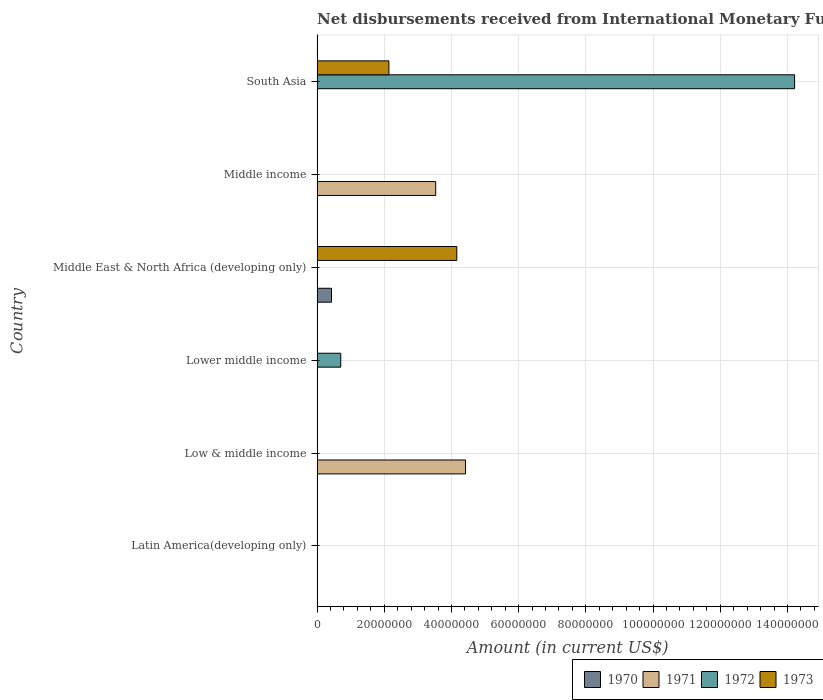How many different coloured bars are there?
Offer a terse response. 4. Are the number of bars per tick equal to the number of legend labels?
Provide a succinct answer. No. Are the number of bars on each tick of the Y-axis equal?
Make the answer very short. No. How many bars are there on the 4th tick from the top?
Offer a very short reply. 1. How many bars are there on the 2nd tick from the bottom?
Your response must be concise. 1. In how many cases, is the number of bars for a given country not equal to the number of legend labels?
Make the answer very short. 6. What is the amount of disbursements received from International Monetary Fund in 1973 in Middle income?
Offer a terse response. 0. Across all countries, what is the maximum amount of disbursements received from International Monetary Fund in 1971?
Provide a succinct answer. 4.42e+07. In which country was the amount of disbursements received from International Monetary Fund in 1971 maximum?
Your response must be concise. Low & middle income. What is the total amount of disbursements received from International Monetary Fund in 1970 in the graph?
Ensure brevity in your answer.  4.30e+06. What is the difference between the amount of disbursements received from International Monetary Fund in 1973 in Lower middle income and the amount of disbursements received from International Monetary Fund in 1970 in Middle East & North Africa (developing only)?
Your response must be concise. -4.30e+06. What is the average amount of disbursements received from International Monetary Fund in 1970 per country?
Ensure brevity in your answer.  7.17e+05. Is the amount of disbursements received from International Monetary Fund in 1972 in Lower middle income less than that in South Asia?
Give a very brief answer. Yes. What is the difference between the highest and the lowest amount of disbursements received from International Monetary Fund in 1970?
Offer a very short reply. 4.30e+06. How many bars are there?
Your response must be concise. 7. Are all the bars in the graph horizontal?
Provide a succinct answer. Yes. Does the graph contain any zero values?
Your answer should be very brief. Yes. Does the graph contain grids?
Give a very brief answer. Yes. Where does the legend appear in the graph?
Your response must be concise. Bottom right. How many legend labels are there?
Offer a terse response. 4. How are the legend labels stacked?
Offer a very short reply. Horizontal. What is the title of the graph?
Provide a succinct answer. Net disbursements received from International Monetary Fund (non-concessional). Does "2005" appear as one of the legend labels in the graph?
Provide a succinct answer. No. What is the label or title of the Y-axis?
Provide a succinct answer. Country. What is the Amount (in current US$) in 1971 in Latin America(developing only)?
Offer a terse response. 0. What is the Amount (in current US$) in 1973 in Latin America(developing only)?
Your answer should be compact. 0. What is the Amount (in current US$) in 1971 in Low & middle income?
Keep it short and to the point. 4.42e+07. What is the Amount (in current US$) in 1973 in Low & middle income?
Your answer should be very brief. 0. What is the Amount (in current US$) of 1970 in Lower middle income?
Your answer should be very brief. 0. What is the Amount (in current US$) of 1972 in Lower middle income?
Your response must be concise. 7.06e+06. What is the Amount (in current US$) of 1970 in Middle East & North Africa (developing only)?
Your response must be concise. 4.30e+06. What is the Amount (in current US$) of 1973 in Middle East & North Africa (developing only)?
Make the answer very short. 4.16e+07. What is the Amount (in current US$) in 1970 in Middle income?
Keep it short and to the point. 0. What is the Amount (in current US$) of 1971 in Middle income?
Your answer should be very brief. 3.53e+07. What is the Amount (in current US$) of 1972 in Middle income?
Ensure brevity in your answer.  0. What is the Amount (in current US$) of 1971 in South Asia?
Your answer should be compact. 0. What is the Amount (in current US$) of 1972 in South Asia?
Your answer should be compact. 1.42e+08. What is the Amount (in current US$) of 1973 in South Asia?
Provide a short and direct response. 2.14e+07. Across all countries, what is the maximum Amount (in current US$) in 1970?
Ensure brevity in your answer.  4.30e+06. Across all countries, what is the maximum Amount (in current US$) in 1971?
Provide a succinct answer. 4.42e+07. Across all countries, what is the maximum Amount (in current US$) of 1972?
Give a very brief answer. 1.42e+08. Across all countries, what is the maximum Amount (in current US$) of 1973?
Offer a terse response. 4.16e+07. Across all countries, what is the minimum Amount (in current US$) of 1971?
Provide a short and direct response. 0. Across all countries, what is the minimum Amount (in current US$) of 1973?
Your answer should be compact. 0. What is the total Amount (in current US$) in 1970 in the graph?
Your answer should be compact. 4.30e+06. What is the total Amount (in current US$) in 1971 in the graph?
Your answer should be very brief. 7.95e+07. What is the total Amount (in current US$) of 1972 in the graph?
Offer a terse response. 1.49e+08. What is the total Amount (in current US$) of 1973 in the graph?
Provide a succinct answer. 6.30e+07. What is the difference between the Amount (in current US$) of 1971 in Low & middle income and that in Middle income?
Your answer should be compact. 8.88e+06. What is the difference between the Amount (in current US$) in 1972 in Lower middle income and that in South Asia?
Keep it short and to the point. -1.35e+08. What is the difference between the Amount (in current US$) of 1973 in Middle East & North Africa (developing only) and that in South Asia?
Your answer should be very brief. 2.02e+07. What is the difference between the Amount (in current US$) of 1971 in Low & middle income and the Amount (in current US$) of 1972 in Lower middle income?
Keep it short and to the point. 3.71e+07. What is the difference between the Amount (in current US$) in 1971 in Low & middle income and the Amount (in current US$) in 1973 in Middle East & North Africa (developing only)?
Keep it short and to the point. 2.60e+06. What is the difference between the Amount (in current US$) in 1971 in Low & middle income and the Amount (in current US$) in 1972 in South Asia?
Ensure brevity in your answer.  -9.79e+07. What is the difference between the Amount (in current US$) of 1971 in Low & middle income and the Amount (in current US$) of 1973 in South Asia?
Your answer should be very brief. 2.28e+07. What is the difference between the Amount (in current US$) in 1972 in Lower middle income and the Amount (in current US$) in 1973 in Middle East & North Africa (developing only)?
Offer a very short reply. -3.45e+07. What is the difference between the Amount (in current US$) in 1972 in Lower middle income and the Amount (in current US$) in 1973 in South Asia?
Your answer should be compact. -1.43e+07. What is the difference between the Amount (in current US$) of 1970 in Middle East & North Africa (developing only) and the Amount (in current US$) of 1971 in Middle income?
Keep it short and to the point. -3.10e+07. What is the difference between the Amount (in current US$) of 1970 in Middle East & North Africa (developing only) and the Amount (in current US$) of 1972 in South Asia?
Provide a short and direct response. -1.38e+08. What is the difference between the Amount (in current US$) of 1970 in Middle East & North Africa (developing only) and the Amount (in current US$) of 1973 in South Asia?
Your answer should be very brief. -1.71e+07. What is the difference between the Amount (in current US$) of 1971 in Middle income and the Amount (in current US$) of 1972 in South Asia?
Provide a short and direct response. -1.07e+08. What is the difference between the Amount (in current US$) in 1971 in Middle income and the Amount (in current US$) in 1973 in South Asia?
Keep it short and to the point. 1.39e+07. What is the average Amount (in current US$) in 1970 per country?
Your answer should be very brief. 7.17e+05. What is the average Amount (in current US$) of 1971 per country?
Your answer should be compact. 1.32e+07. What is the average Amount (in current US$) in 1972 per country?
Offer a very short reply. 2.49e+07. What is the average Amount (in current US$) in 1973 per country?
Make the answer very short. 1.05e+07. What is the difference between the Amount (in current US$) of 1970 and Amount (in current US$) of 1973 in Middle East & North Africa (developing only)?
Provide a succinct answer. -3.73e+07. What is the difference between the Amount (in current US$) in 1972 and Amount (in current US$) in 1973 in South Asia?
Provide a succinct answer. 1.21e+08. What is the ratio of the Amount (in current US$) in 1971 in Low & middle income to that in Middle income?
Your response must be concise. 1.25. What is the ratio of the Amount (in current US$) in 1972 in Lower middle income to that in South Asia?
Keep it short and to the point. 0.05. What is the ratio of the Amount (in current US$) of 1973 in Middle East & North Africa (developing only) to that in South Asia?
Your answer should be compact. 1.94. What is the difference between the highest and the lowest Amount (in current US$) in 1970?
Keep it short and to the point. 4.30e+06. What is the difference between the highest and the lowest Amount (in current US$) in 1971?
Offer a terse response. 4.42e+07. What is the difference between the highest and the lowest Amount (in current US$) in 1972?
Provide a short and direct response. 1.42e+08. What is the difference between the highest and the lowest Amount (in current US$) of 1973?
Ensure brevity in your answer.  4.16e+07. 